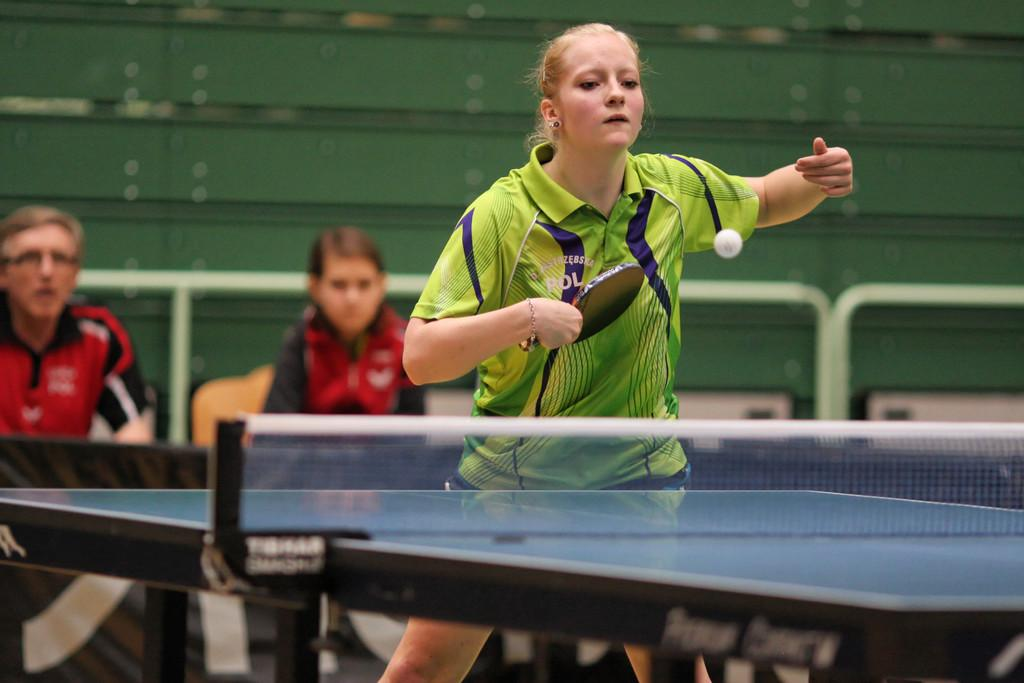Who is the main subject in the image? There is a woman in the image. What is the woman wearing? The woman is wearing a green jersey. What activity is the woman engaged in? The woman is playing table tennis. What type of area is visible in the image? There is a play area for table tennis in the image. How many people are present in the play area? There is a woman and a man in the play area. What type of memory does the woman have in the image? There is no mention of a memory in the image; it features a woman playing table tennis in a play area. 